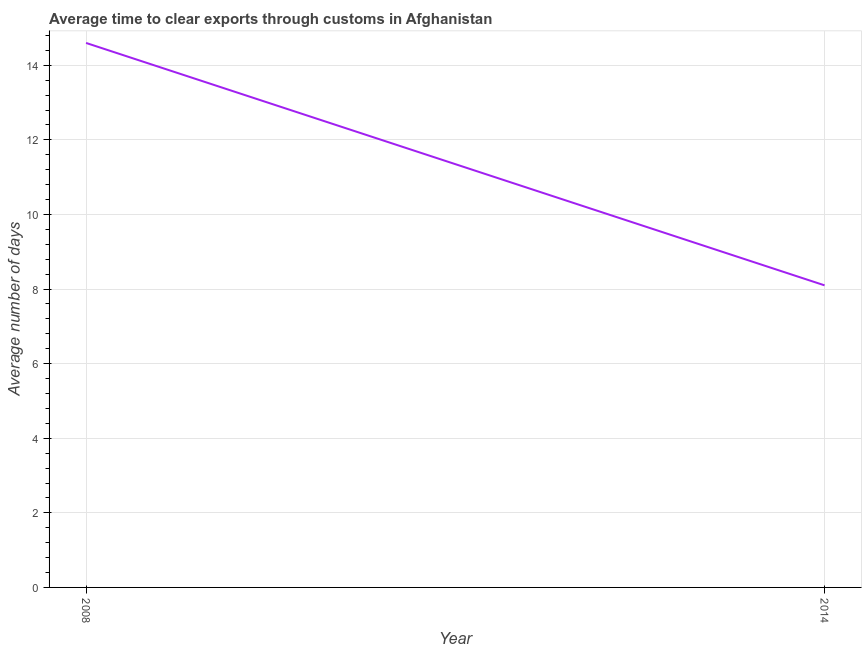Across all years, what is the maximum time to clear exports through customs?
Ensure brevity in your answer.  14.6. Across all years, what is the minimum time to clear exports through customs?
Provide a succinct answer. 8.1. In which year was the time to clear exports through customs maximum?
Offer a very short reply. 2008. In which year was the time to clear exports through customs minimum?
Your response must be concise. 2014. What is the sum of the time to clear exports through customs?
Offer a very short reply. 22.7. What is the average time to clear exports through customs per year?
Offer a very short reply. 11.35. What is the median time to clear exports through customs?
Keep it short and to the point. 11.35. What is the ratio of the time to clear exports through customs in 2008 to that in 2014?
Keep it short and to the point. 1.8. How many years are there in the graph?
Give a very brief answer. 2. Are the values on the major ticks of Y-axis written in scientific E-notation?
Ensure brevity in your answer.  No. Does the graph contain grids?
Make the answer very short. Yes. What is the title of the graph?
Your answer should be very brief. Average time to clear exports through customs in Afghanistan. What is the label or title of the X-axis?
Give a very brief answer. Year. What is the label or title of the Y-axis?
Keep it short and to the point. Average number of days. What is the difference between the Average number of days in 2008 and 2014?
Provide a short and direct response. 6.5. What is the ratio of the Average number of days in 2008 to that in 2014?
Your answer should be very brief. 1.8. 